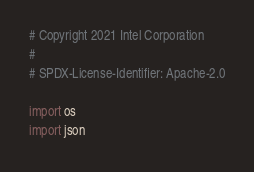<code> <loc_0><loc_0><loc_500><loc_500><_Python_># Copyright 2021 Intel Corporation
#
# SPDX-License-Identifier: Apache-2.0

import os
import json</code> 